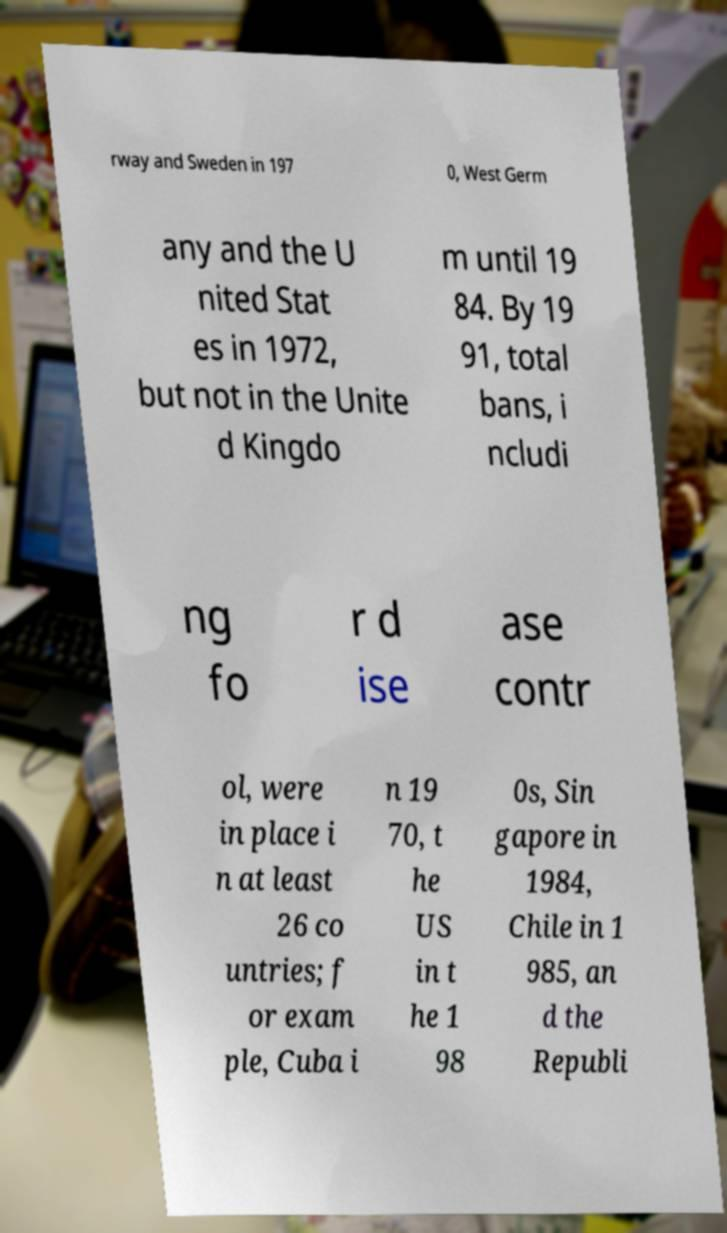Please identify and transcribe the text found in this image. rway and Sweden in 197 0, West Germ any and the U nited Stat es in 1972, but not in the Unite d Kingdo m until 19 84. By 19 91, total bans, i ncludi ng fo r d ise ase contr ol, were in place i n at least 26 co untries; f or exam ple, Cuba i n 19 70, t he US in t he 1 98 0s, Sin gapore in 1984, Chile in 1 985, an d the Republi 